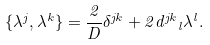Convert formula to latex. <formula><loc_0><loc_0><loc_500><loc_500>\{ \lambda ^ { j } , \lambda ^ { k } \} = \frac { 2 } { D } \delta ^ { j k } + 2 { d ^ { j k } } _ { l } \lambda ^ { l } .</formula> 